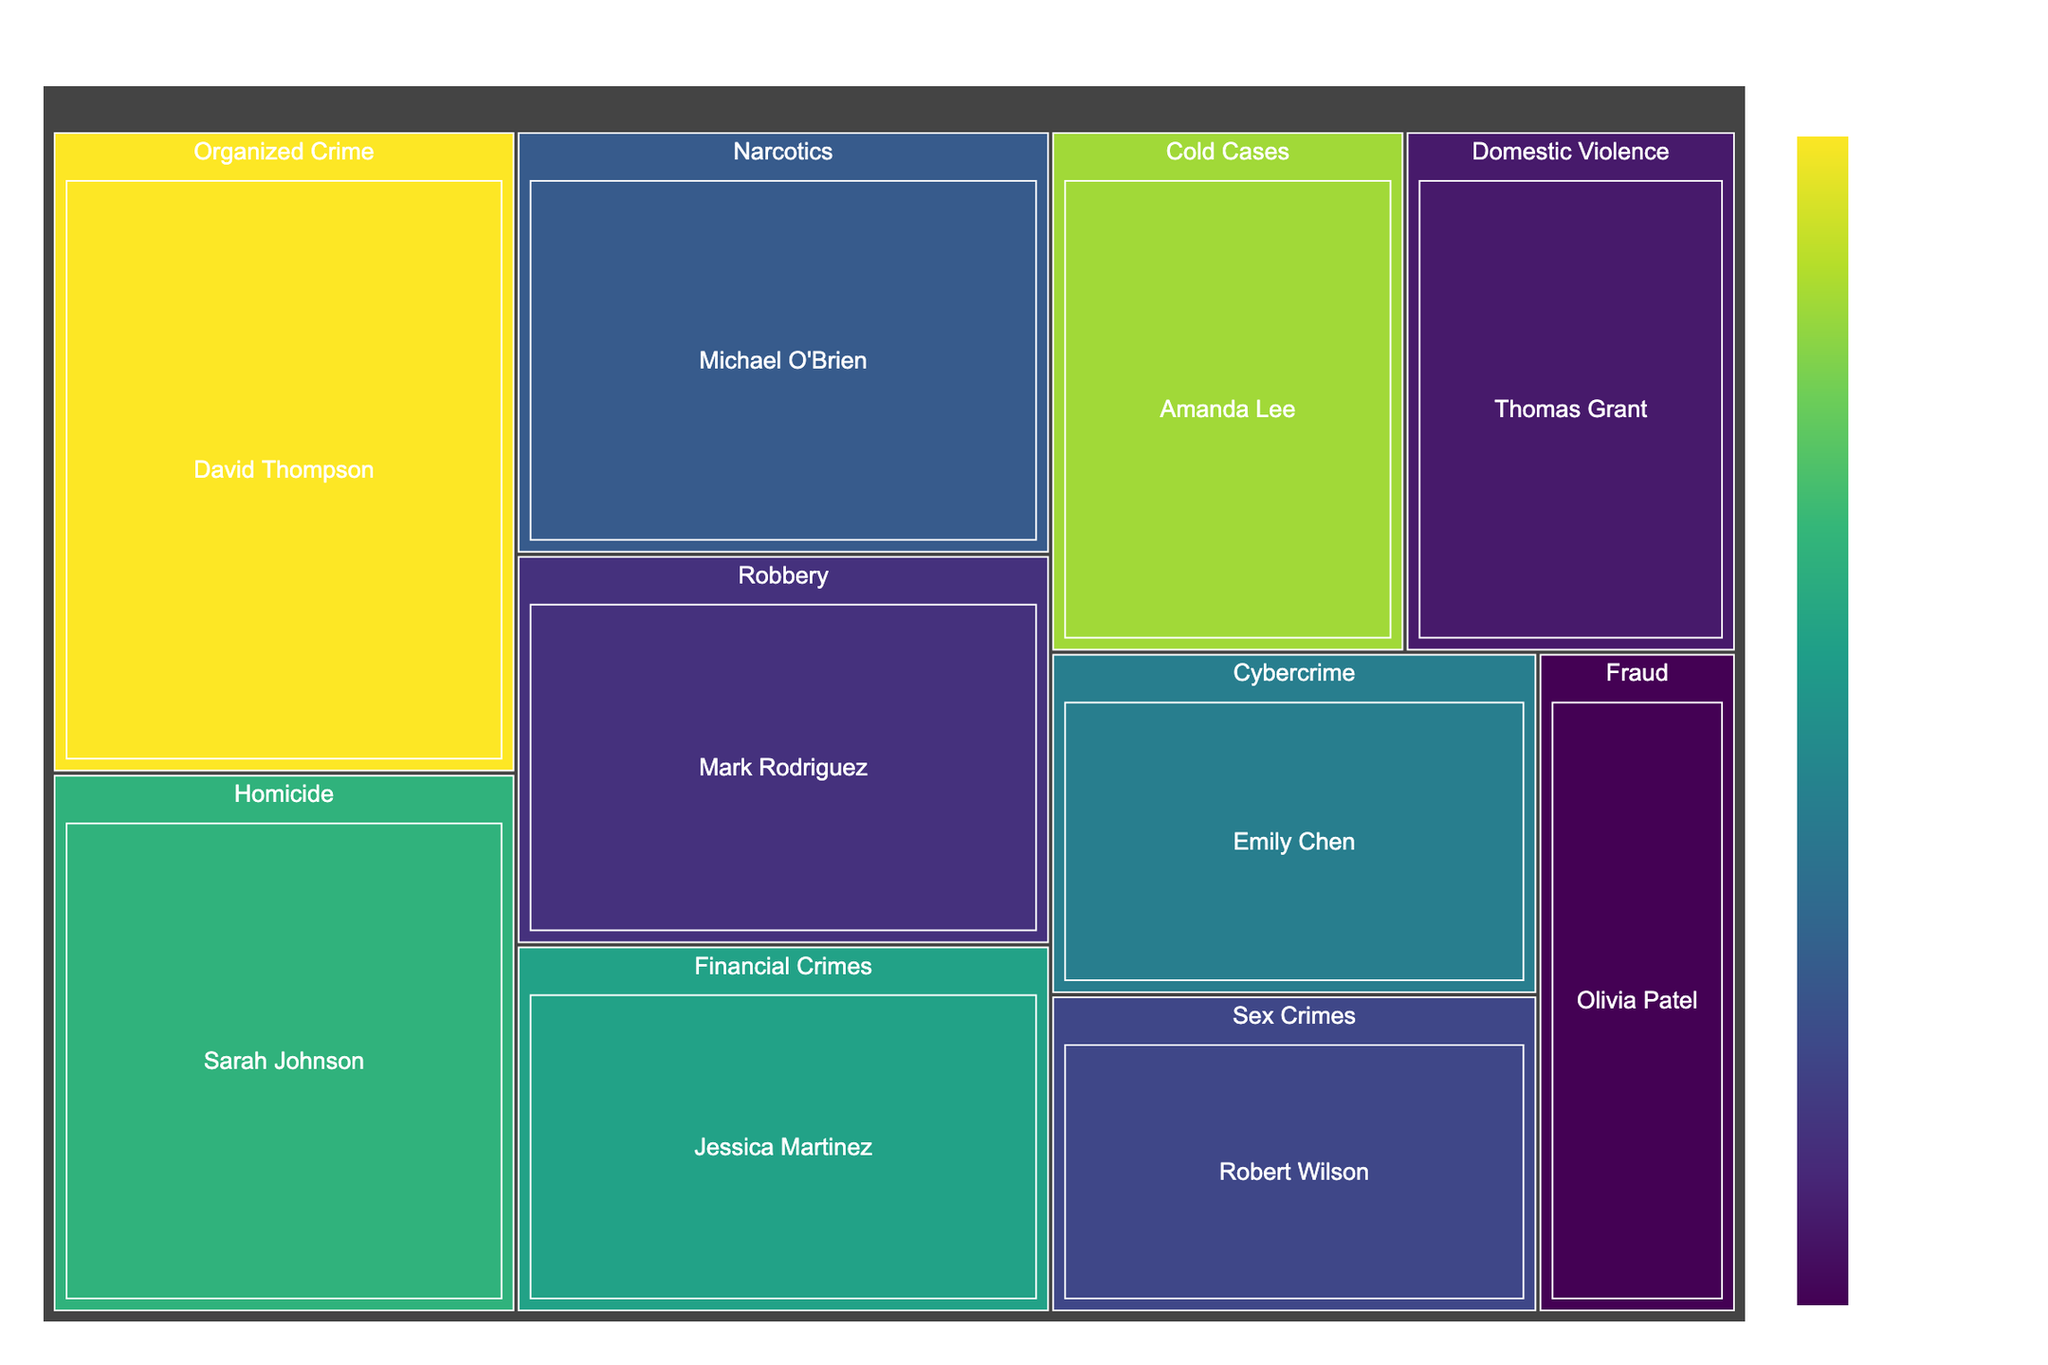What is the title of the treemap? The title is usually located at the top of the plot. It provides a brief summary of what the visualization represents. In this case, based on the description, it should be clearly mentioned at the top of the treemap.
Answer: Breakdown of Solved Cases by Detective Which detective has the most years of experience? To determine this, look for the tile with the highest value in the "Years of Experience" field. This value is usually associated with a darker or different color due to the color gradient used.
Answer: David Thompson Who has solved the most cases in the Homicide specialization? Identify the section of the treemap labeled "Homicide" and within that section, find the detective tile with the largest area, which represents the number of solved cases.
Answer: Sarah Johnson What's the combined total of solved cases by Emily Chen and Robert Wilson? Locate the tiles for Emily Chen and Robert Wilson in the treemap. Sum their values for solved cases. Emily Chen has 28 solved cases, and Robert Wilson has 26 solved cases. The combined total is 28 + 26.
Answer: 54 Which specialization has the least number of solved cases? Look at the labels in the treemap for each specialization and identify the one with the smallest combined area across all detectives in that specialization.
Answer: Fraud How many more cases has David Thompson solved compared to Olivia Patel? Find the tiles for David Thompson and Olivia Patel. Note that David Thompson has solved 50 cases, and Olivia Patel has solved 22 cases. Subtract the number of cases solved by Olivia Patel from those solved by David Thompson (50 - 22).
Answer: 28 Who has approximately double the years of experience compared to Mark Rodriguez? Mark Rodriguez has 8 years of experience. Search for a detective with approximately 16 years of experience, which is double of 8 years.
Answer: Amanda Lee (with 18 years of experience) Which detective in the Financial Crimes specialization has solved the most cases? Navigate to the area representing Financial Crimes and locate the tile with the largest size. This tile represents the cases solved by that detective.
Answer: Jessica Martinez Compare the number of solved cases between detectives in Narcotics and Cold Cases. Which specialization has more total solved cases? Summing the solved cases for Narcotics (Michael O'Brien with 38 cases) and for Cold Cases (Amanda Lee with 31 cases), add them up and compare.
Answer: Narcotics (38 cases) has more than Cold Cases (31 cases) What color does the treemap use to indicate higher years of experience? Based on the description, the color scale used is 'Viridis,' where typically, higher values are represented by darker shades. Inspect the color gradient in the legend to confirm this.
Answer: Darker shades 